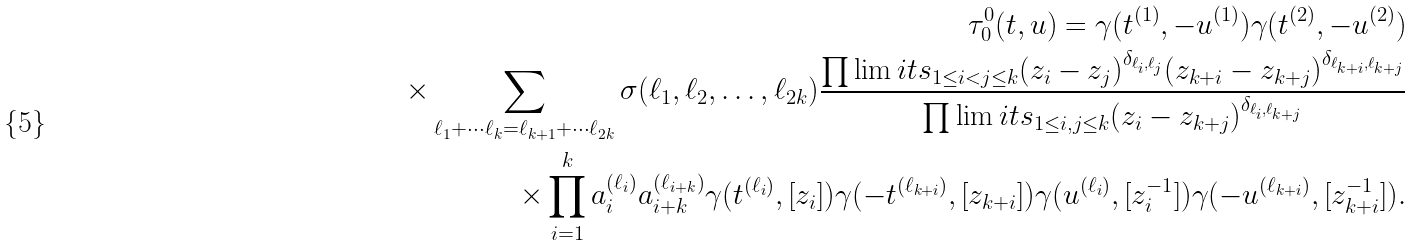<formula> <loc_0><loc_0><loc_500><loc_500>\tau _ { 0 } ^ { 0 } ( t , u ) = \gamma ( t ^ { ( 1 ) } , - u ^ { ( 1 ) } ) \gamma ( t ^ { ( 2 ) } , - u ^ { ( 2 ) } ) \\ \times \sum _ { \ell _ { 1 } + \cdots \ell _ { k } = \ell _ { k + 1 } + \cdots \ell _ { 2 k } } \sigma ( \ell _ { 1 } , \ell _ { 2 } , \dots , \ell _ { 2 k } ) \frac { \prod \lim i t s _ { 1 \leq i < j \leq k } ( z _ { i } - z _ { j } ) ^ { \delta _ { \ell _ { i } , \ell _ { j } } } ( z _ { k + i } - z _ { k + j } ) ^ { \delta _ { \ell _ { k + i } , \ell _ { k + j } } } } { \prod \lim i t s _ { 1 \leq i , j \leq k } ( z _ { i } - z _ { k + j } ) ^ { \delta _ { \ell _ { i } , \ell _ { k + j } } } } \\ \times \prod _ { i = 1 } ^ { k } a _ { i } ^ { ( \ell _ { i } ) } a _ { i + k } ^ { ( \ell _ { i + k } ) } \gamma ( t ^ { ( \ell _ { i } ) } , [ z _ { i } ] ) \gamma ( - t ^ { ( \ell _ { k + i } ) } , [ z _ { k + i } ] ) \gamma ( u ^ { ( \ell _ { i } ) } , [ z _ { i } ^ { - 1 } ] ) \gamma ( - u ^ { ( \ell _ { k + i } ) } , [ z _ { k + i } ^ { - 1 } ] ) .</formula> 